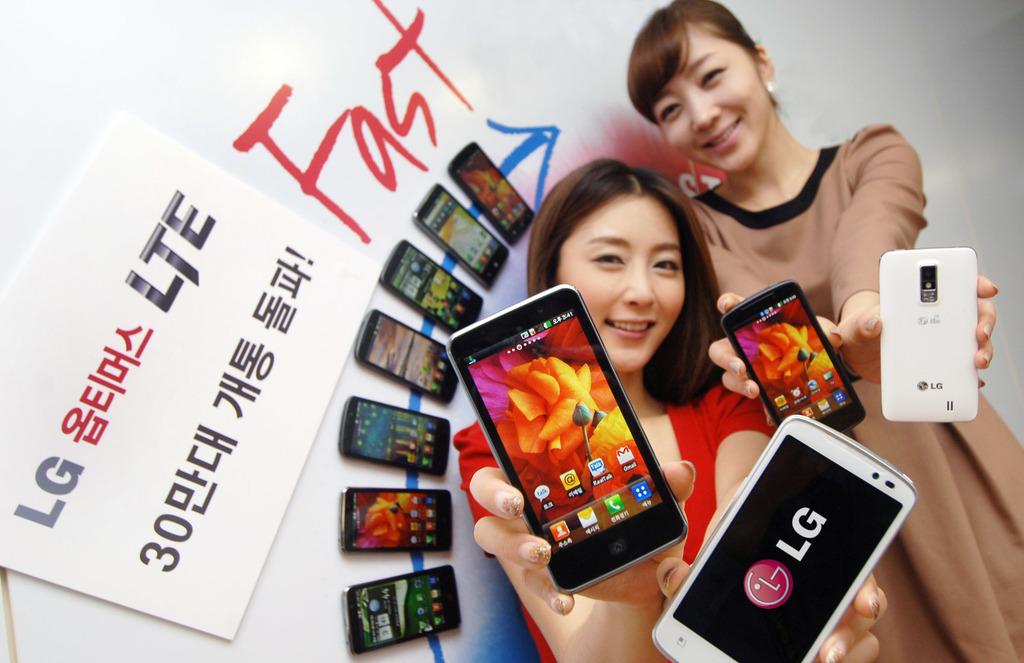Who is the manufacturer?
Provide a succinct answer. Lg. What kind of network is on this phone?
Your response must be concise. Lte. 